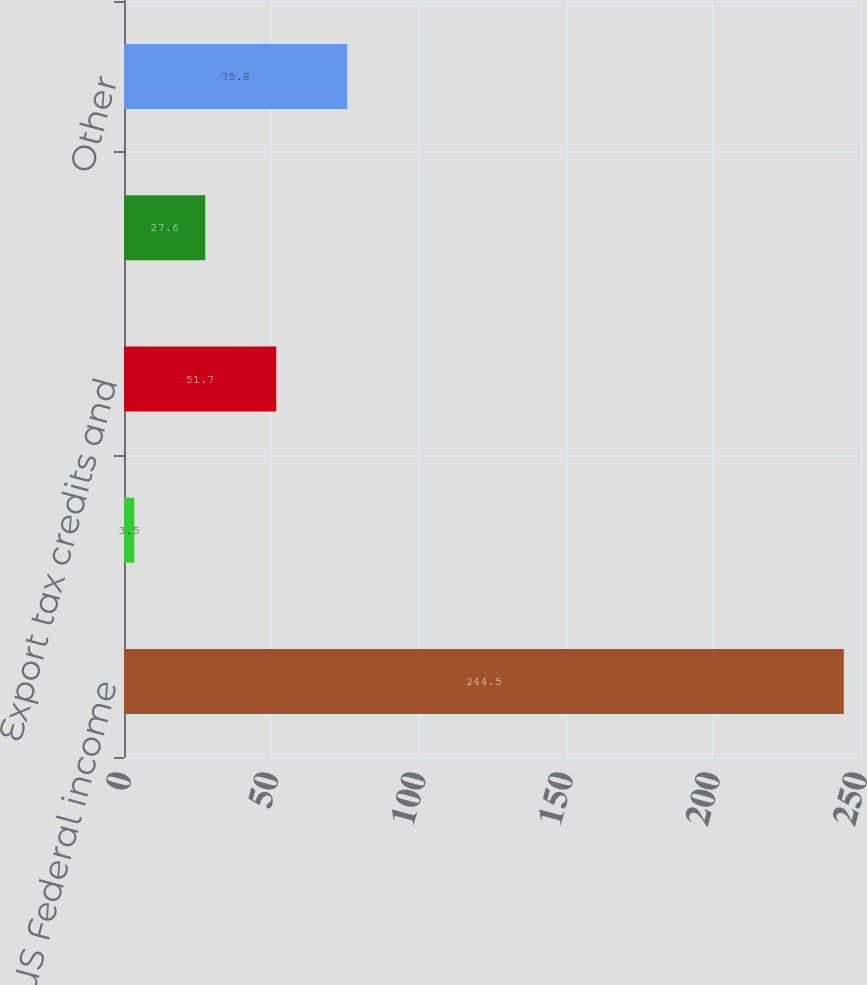Convert chart to OTSL. <chart><loc_0><loc_0><loc_500><loc_500><bar_chart><fcel>Computed US Federal income<fcel>State income taxes net of US<fcel>Export tax credits and<fcel>Foreign tax credits<fcel>Other<nl><fcel>244.5<fcel>3.5<fcel>51.7<fcel>27.6<fcel>75.8<nl></chart> 